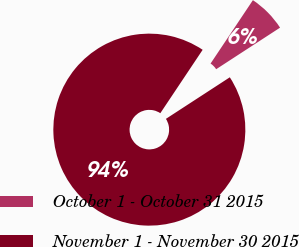Convert chart to OTSL. <chart><loc_0><loc_0><loc_500><loc_500><pie_chart><fcel>October 1 - October 31 2015<fcel>November 1 - November 30 2015<nl><fcel>6.45%<fcel>93.55%<nl></chart> 